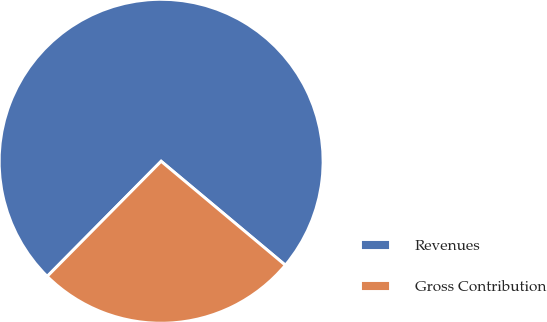Convert chart. <chart><loc_0><loc_0><loc_500><loc_500><pie_chart><fcel>Revenues<fcel>Gross Contribution<nl><fcel>73.67%<fcel>26.33%<nl></chart> 